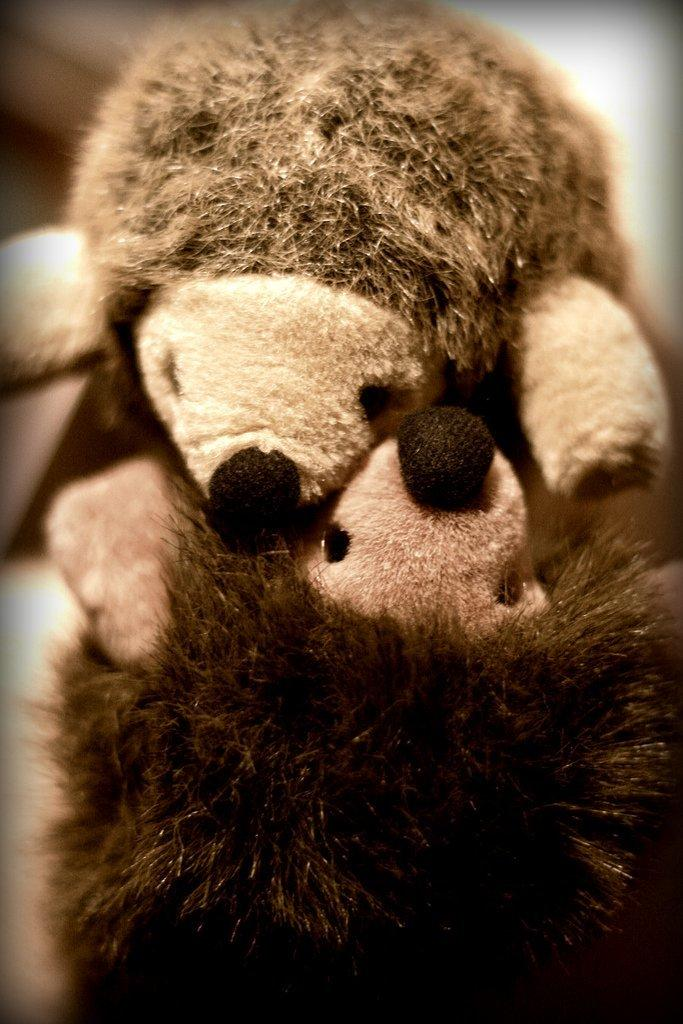What type of objects can be seen in the image? There are toys in the image. How many pears are visible in the image? There are no pears present in the image; it features toys. What type of grape is being stored in the jar in the image? There is no jar or grape present in the image. 